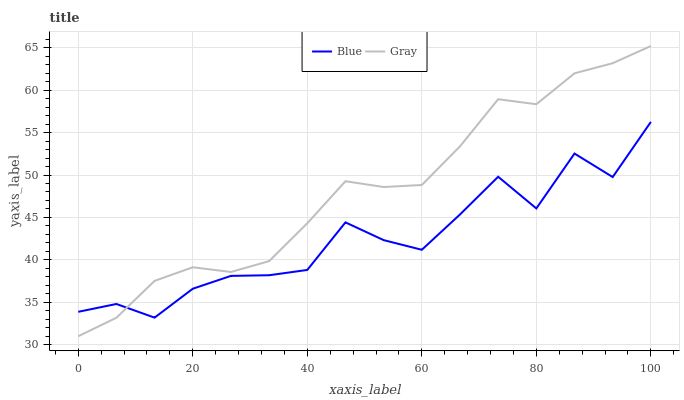Does Blue have the minimum area under the curve?
Answer yes or no. Yes. Does Gray have the maximum area under the curve?
Answer yes or no. Yes. Does Gray have the minimum area under the curve?
Answer yes or no. No. Is Gray the smoothest?
Answer yes or no. Yes. Is Blue the roughest?
Answer yes or no. Yes. Is Gray the roughest?
Answer yes or no. No. 